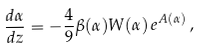<formula> <loc_0><loc_0><loc_500><loc_500>\frac { d \alpha } { d z } = - \frac { 4 } { 9 } \beta ( \alpha ) W ( \alpha ) \, e ^ { A ( \alpha ) } \, ,</formula> 